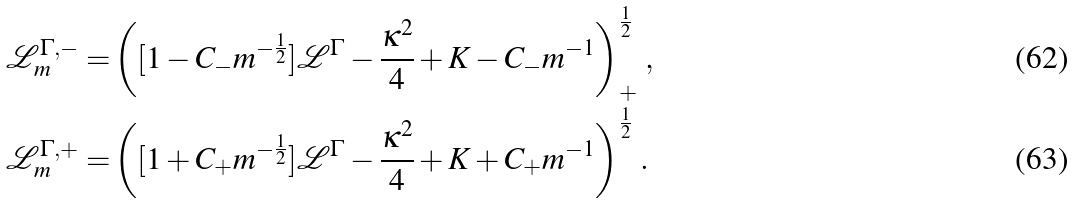Convert formula to latex. <formula><loc_0><loc_0><loc_500><loc_500>\mathcal { L } _ { m } ^ { \Gamma , - } = & \left ( [ 1 - C _ { - } m ^ { - \frac { 1 } { 2 } } ] \mathcal { L } ^ { \Gamma } - \frac { \kappa ^ { 2 } } { 4 } + K - C _ { - } m ^ { - 1 } \right ) _ { + } ^ { \frac { 1 } { 2 } } \, , \\ \mathcal { L } _ { m } ^ { \Gamma , + } = & \left ( [ 1 + C _ { + } m ^ { - \frac { 1 } { 2 } } ] \mathcal { L } ^ { \Gamma } - \frac { \kappa ^ { 2 } } { 4 } + K + C _ { + } m ^ { - 1 } \right ) ^ { \frac { 1 } { 2 } } \, .</formula> 